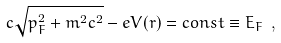Convert formula to latex. <formula><loc_0><loc_0><loc_500><loc_500>c \sqrt { p _ { F } ^ { 2 } + m ^ { 2 } c ^ { 2 } } - e V ( r ) = c o n s t \equiv E _ { F } \ ,</formula> 